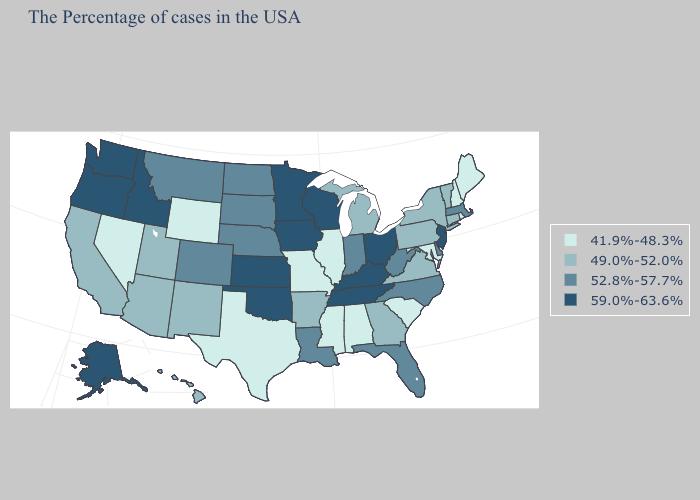Name the states that have a value in the range 52.8%-57.7%?
Keep it brief. Massachusetts, Delaware, North Carolina, West Virginia, Florida, Indiana, Louisiana, Nebraska, South Dakota, North Dakota, Colorado, Montana. Name the states that have a value in the range 41.9%-48.3%?
Keep it brief. Maine, Rhode Island, New Hampshire, Maryland, South Carolina, Alabama, Illinois, Mississippi, Missouri, Texas, Wyoming, Nevada. Does Alaska have the highest value in the USA?
Answer briefly. Yes. Name the states that have a value in the range 59.0%-63.6%?
Answer briefly. New Jersey, Ohio, Kentucky, Tennessee, Wisconsin, Minnesota, Iowa, Kansas, Oklahoma, Idaho, Washington, Oregon, Alaska. Name the states that have a value in the range 52.8%-57.7%?
Quick response, please. Massachusetts, Delaware, North Carolina, West Virginia, Florida, Indiana, Louisiana, Nebraska, South Dakota, North Dakota, Colorado, Montana. Does the map have missing data?
Give a very brief answer. No. Does the map have missing data?
Concise answer only. No. Which states hav the highest value in the South?
Concise answer only. Kentucky, Tennessee, Oklahoma. Name the states that have a value in the range 49.0%-52.0%?
Write a very short answer. Vermont, Connecticut, New York, Pennsylvania, Virginia, Georgia, Michigan, Arkansas, New Mexico, Utah, Arizona, California, Hawaii. What is the highest value in states that border Washington?
Write a very short answer. 59.0%-63.6%. Does Delaware have the same value as Kentucky?
Be succinct. No. What is the lowest value in the USA?
Short answer required. 41.9%-48.3%. Which states have the lowest value in the MidWest?
Concise answer only. Illinois, Missouri. Name the states that have a value in the range 52.8%-57.7%?
Concise answer only. Massachusetts, Delaware, North Carolina, West Virginia, Florida, Indiana, Louisiana, Nebraska, South Dakota, North Dakota, Colorado, Montana. What is the highest value in the West ?
Concise answer only. 59.0%-63.6%. 